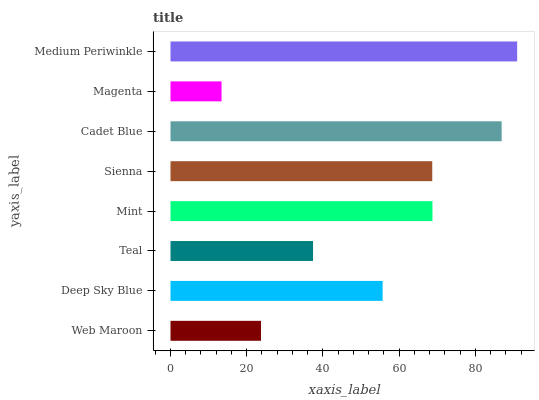Is Magenta the minimum?
Answer yes or no. Yes. Is Medium Periwinkle the maximum?
Answer yes or no. Yes. Is Deep Sky Blue the minimum?
Answer yes or no. No. Is Deep Sky Blue the maximum?
Answer yes or no. No. Is Deep Sky Blue greater than Web Maroon?
Answer yes or no. Yes. Is Web Maroon less than Deep Sky Blue?
Answer yes or no. Yes. Is Web Maroon greater than Deep Sky Blue?
Answer yes or no. No. Is Deep Sky Blue less than Web Maroon?
Answer yes or no. No. Is Sienna the high median?
Answer yes or no. Yes. Is Deep Sky Blue the low median?
Answer yes or no. Yes. Is Teal the high median?
Answer yes or no. No. Is Magenta the low median?
Answer yes or no. No. 